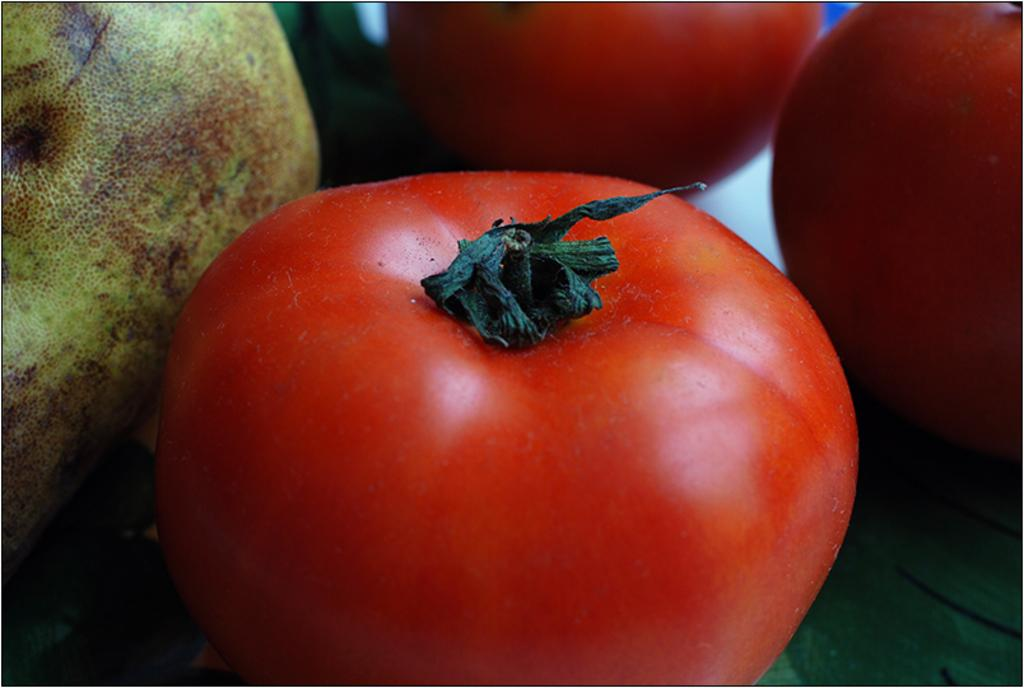What color is the tomato in the image? The tomato in the image is red. How many other tomatoes are present in the image? There are two other tomatoes in front of the red tomato. Can you describe the object in the left corner of the image? Unfortunately, the facts provided do not give any information about the object in the left corner of the image. What type of veil is draped over the tomato in the image? There is no veil present in the image; it is a picture of tomatoes. 